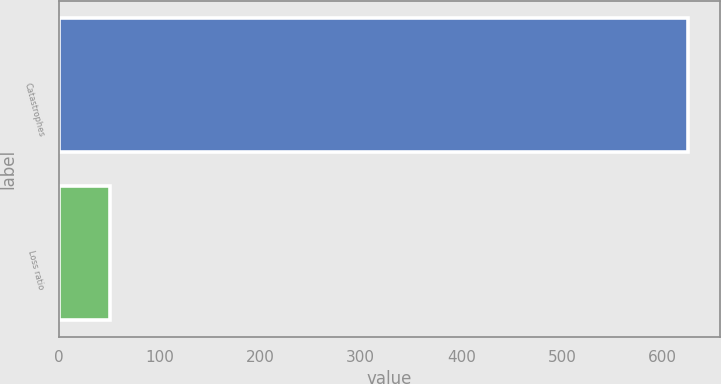Convert chart. <chart><loc_0><loc_0><loc_500><loc_500><bar_chart><fcel>Catastrophes<fcel>Loss ratio<nl><fcel>625.7<fcel>50.4<nl></chart> 